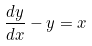Convert formula to latex. <formula><loc_0><loc_0><loc_500><loc_500>\frac { d y } { d x } - y = x</formula> 